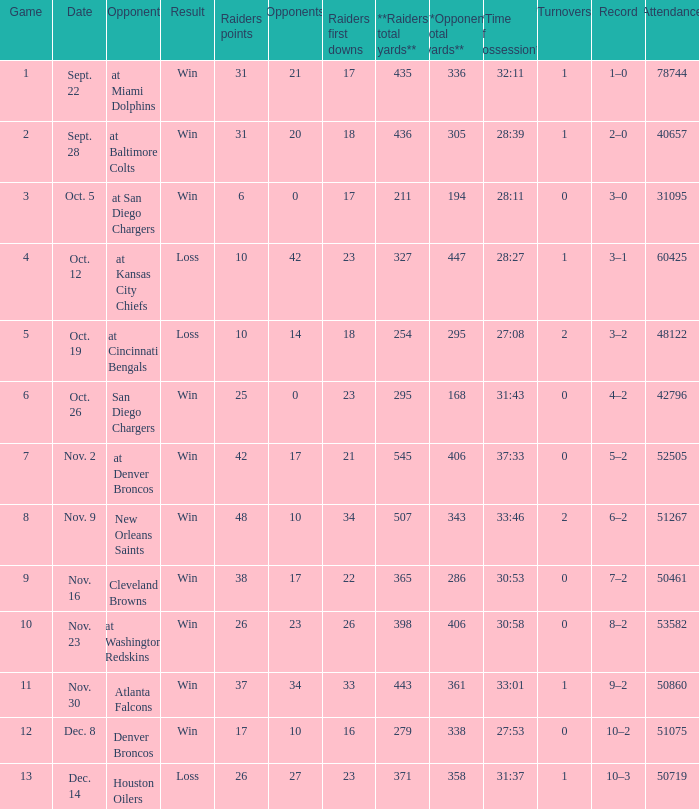How many opponents played 1 game with a result win? 21.0. 